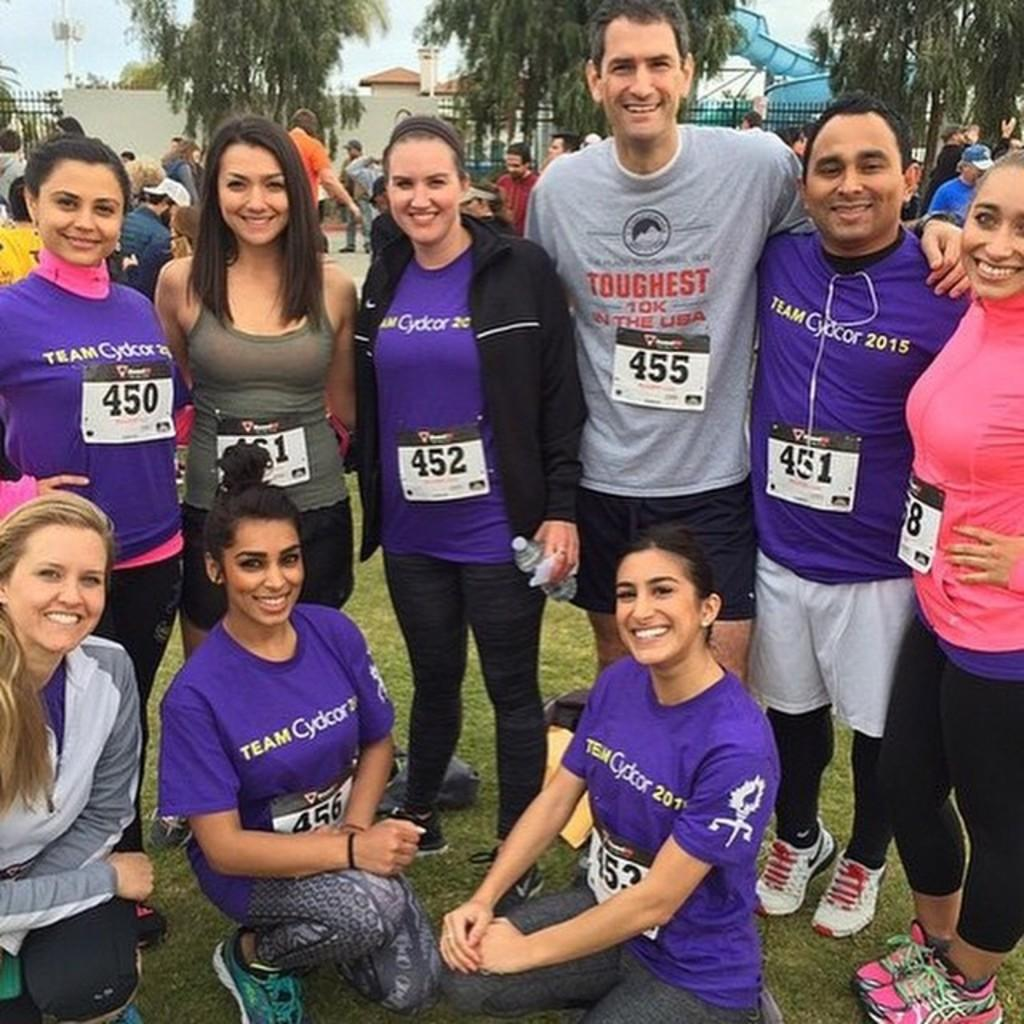How many people are in the image? There is a group of people in the image, but the exact number is not specified. What are the people in the image doing? Some people are sitting, while others are standing. What can be seen in the background of the image? There are buildings and trees with green color in the background. What is the color of the sky in the image? The sky is visible in the background, and it appears to be white in color. What type of needle is being used by the person in the image? There is no needle present in the image. What is the thing that the person in the image is holding? The provided facts do not mention any specific object being held by a person in the image. 